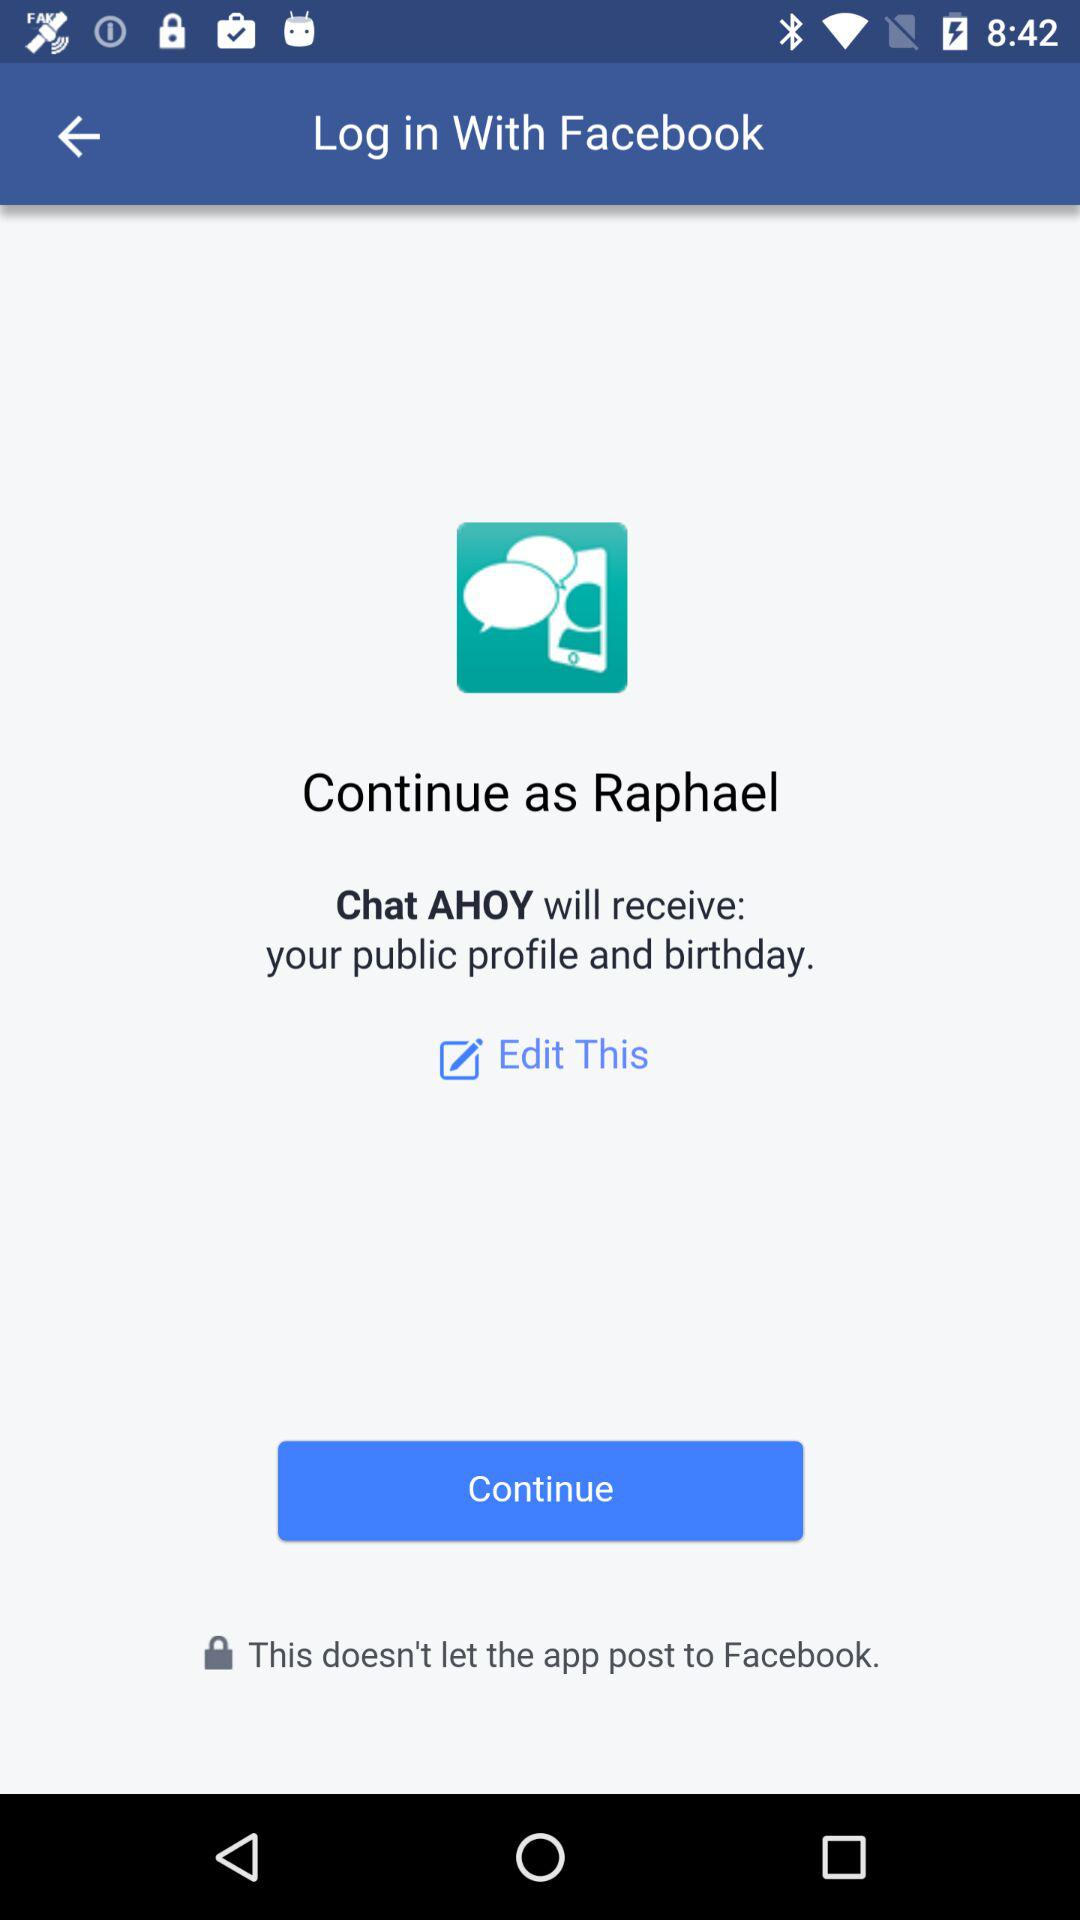What is the user name? The user name is Raphael. 